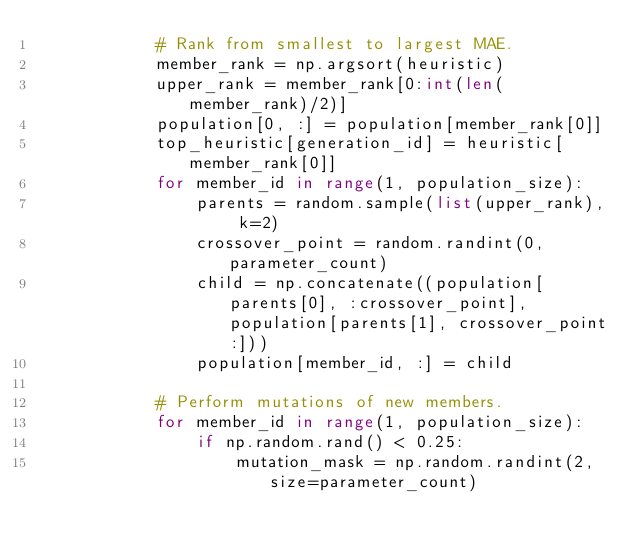<code> <loc_0><loc_0><loc_500><loc_500><_Python_>            # Rank from smallest to largest MAE.
            member_rank = np.argsort(heuristic)
            upper_rank = member_rank[0:int(len(member_rank)/2)]
            population[0, :] = population[member_rank[0]]
            top_heuristic[generation_id] = heuristic[member_rank[0]]
            for member_id in range(1, population_size):
                parents = random.sample(list(upper_rank), k=2)
                crossover_point = random.randint(0,parameter_count)
                child = np.concatenate((population[parents[0], :crossover_point], population[parents[1], crossover_point:]))
                population[member_id, :] = child
            
            # Perform mutations of new members.
            for member_id in range(1, population_size):
                if np.random.rand() < 0.25:
                    mutation_mask = np.random.randint(2, size=parameter_count)</code> 